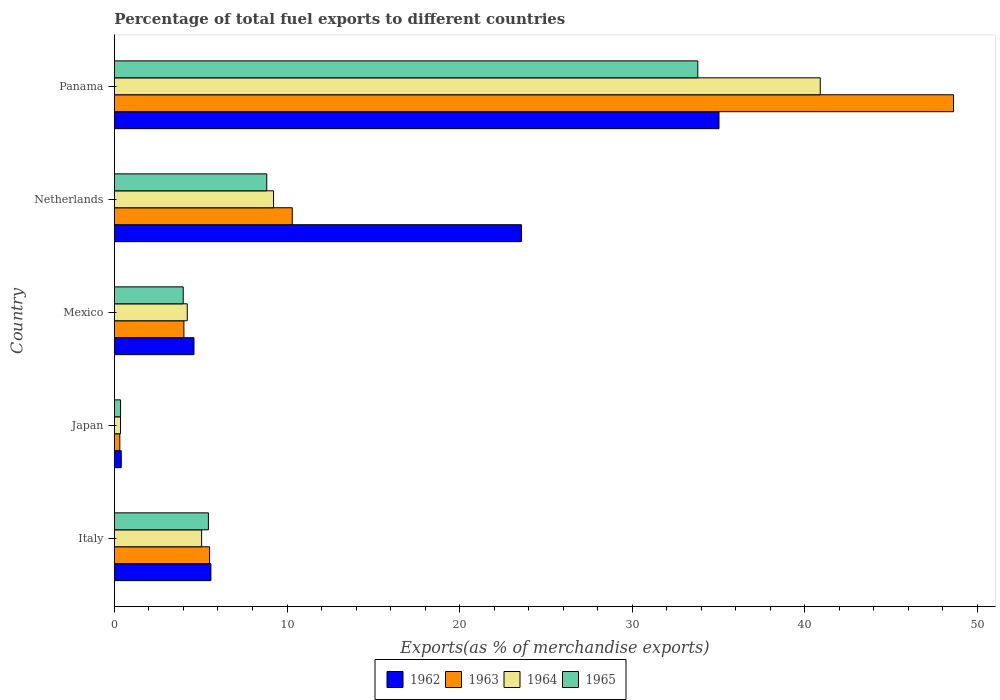Are the number of bars per tick equal to the number of legend labels?
Provide a succinct answer. Yes. What is the label of the 3rd group of bars from the top?
Provide a succinct answer. Mexico. In how many cases, is the number of bars for a given country not equal to the number of legend labels?
Your response must be concise. 0. What is the percentage of exports to different countries in 1965 in Mexico?
Offer a terse response. 3.99. Across all countries, what is the maximum percentage of exports to different countries in 1965?
Give a very brief answer. 33.8. Across all countries, what is the minimum percentage of exports to different countries in 1962?
Offer a very short reply. 0.4. In which country was the percentage of exports to different countries in 1965 maximum?
Make the answer very short. Panama. What is the total percentage of exports to different countries in 1965 in the graph?
Offer a terse response. 52.41. What is the difference between the percentage of exports to different countries in 1963 in Italy and that in Japan?
Ensure brevity in your answer.  5.2. What is the difference between the percentage of exports to different countries in 1963 in Italy and the percentage of exports to different countries in 1964 in Mexico?
Offer a very short reply. 1.29. What is the average percentage of exports to different countries in 1964 per country?
Offer a terse response. 11.95. What is the difference between the percentage of exports to different countries in 1963 and percentage of exports to different countries in 1964 in Japan?
Make the answer very short. -0.04. What is the ratio of the percentage of exports to different countries in 1964 in Japan to that in Mexico?
Make the answer very short. 0.08. Is the percentage of exports to different countries in 1965 in Mexico less than that in Panama?
Your answer should be compact. Yes. Is the difference between the percentage of exports to different countries in 1963 in Italy and Mexico greater than the difference between the percentage of exports to different countries in 1964 in Italy and Mexico?
Keep it short and to the point. Yes. What is the difference between the highest and the second highest percentage of exports to different countries in 1964?
Ensure brevity in your answer.  31.68. What is the difference between the highest and the lowest percentage of exports to different countries in 1965?
Your answer should be very brief. 33.45. Is the sum of the percentage of exports to different countries in 1962 in Mexico and Panama greater than the maximum percentage of exports to different countries in 1963 across all countries?
Give a very brief answer. No. Is it the case that in every country, the sum of the percentage of exports to different countries in 1965 and percentage of exports to different countries in 1964 is greater than the sum of percentage of exports to different countries in 1963 and percentage of exports to different countries in 1962?
Make the answer very short. No. What does the 1st bar from the top in Panama represents?
Your answer should be very brief. 1965. What does the 2nd bar from the bottom in Italy represents?
Provide a succinct answer. 1963. Are all the bars in the graph horizontal?
Your answer should be very brief. Yes. Does the graph contain grids?
Your answer should be very brief. No. Where does the legend appear in the graph?
Provide a succinct answer. Bottom center. How are the legend labels stacked?
Offer a terse response. Horizontal. What is the title of the graph?
Provide a short and direct response. Percentage of total fuel exports to different countries. Does "2003" appear as one of the legend labels in the graph?
Your response must be concise. No. What is the label or title of the X-axis?
Provide a short and direct response. Exports(as % of merchandise exports). What is the label or title of the Y-axis?
Your answer should be very brief. Country. What is the Exports(as % of merchandise exports) in 1962 in Italy?
Provide a succinct answer. 5.59. What is the Exports(as % of merchandise exports) in 1963 in Italy?
Give a very brief answer. 5.51. What is the Exports(as % of merchandise exports) of 1964 in Italy?
Your answer should be very brief. 5.05. What is the Exports(as % of merchandise exports) of 1965 in Italy?
Ensure brevity in your answer.  5.45. What is the Exports(as % of merchandise exports) in 1962 in Japan?
Your answer should be compact. 0.4. What is the Exports(as % of merchandise exports) in 1963 in Japan?
Your answer should be compact. 0.31. What is the Exports(as % of merchandise exports) in 1964 in Japan?
Provide a succinct answer. 0.35. What is the Exports(as % of merchandise exports) of 1965 in Japan?
Offer a very short reply. 0.36. What is the Exports(as % of merchandise exports) in 1962 in Mexico?
Keep it short and to the point. 4.61. What is the Exports(as % of merchandise exports) in 1963 in Mexico?
Ensure brevity in your answer.  4.03. What is the Exports(as % of merchandise exports) of 1964 in Mexico?
Provide a succinct answer. 4.22. What is the Exports(as % of merchandise exports) of 1965 in Mexico?
Your answer should be very brief. 3.99. What is the Exports(as % of merchandise exports) of 1962 in Netherlands?
Give a very brief answer. 23.58. What is the Exports(as % of merchandise exports) of 1963 in Netherlands?
Give a very brief answer. 10.31. What is the Exports(as % of merchandise exports) of 1964 in Netherlands?
Offer a very short reply. 9.22. What is the Exports(as % of merchandise exports) of 1965 in Netherlands?
Give a very brief answer. 8.83. What is the Exports(as % of merchandise exports) of 1962 in Panama?
Make the answer very short. 35.03. What is the Exports(as % of merchandise exports) in 1963 in Panama?
Your answer should be very brief. 48.62. What is the Exports(as % of merchandise exports) of 1964 in Panama?
Make the answer very short. 40.9. What is the Exports(as % of merchandise exports) of 1965 in Panama?
Give a very brief answer. 33.8. Across all countries, what is the maximum Exports(as % of merchandise exports) of 1962?
Ensure brevity in your answer.  35.03. Across all countries, what is the maximum Exports(as % of merchandise exports) of 1963?
Your answer should be compact. 48.62. Across all countries, what is the maximum Exports(as % of merchandise exports) in 1964?
Your answer should be very brief. 40.9. Across all countries, what is the maximum Exports(as % of merchandise exports) of 1965?
Your answer should be compact. 33.8. Across all countries, what is the minimum Exports(as % of merchandise exports) of 1962?
Your response must be concise. 0.4. Across all countries, what is the minimum Exports(as % of merchandise exports) in 1963?
Your response must be concise. 0.31. Across all countries, what is the minimum Exports(as % of merchandise exports) of 1964?
Offer a very short reply. 0.35. Across all countries, what is the minimum Exports(as % of merchandise exports) in 1965?
Your answer should be compact. 0.36. What is the total Exports(as % of merchandise exports) of 1962 in the graph?
Make the answer very short. 69.21. What is the total Exports(as % of merchandise exports) in 1963 in the graph?
Provide a succinct answer. 68.78. What is the total Exports(as % of merchandise exports) in 1964 in the graph?
Provide a succinct answer. 59.74. What is the total Exports(as % of merchandise exports) of 1965 in the graph?
Your response must be concise. 52.41. What is the difference between the Exports(as % of merchandise exports) of 1962 in Italy and that in Japan?
Ensure brevity in your answer.  5.19. What is the difference between the Exports(as % of merchandise exports) in 1963 in Italy and that in Japan?
Keep it short and to the point. 5.2. What is the difference between the Exports(as % of merchandise exports) of 1964 in Italy and that in Japan?
Make the answer very short. 4.7. What is the difference between the Exports(as % of merchandise exports) of 1965 in Italy and that in Japan?
Your answer should be very brief. 5.09. What is the difference between the Exports(as % of merchandise exports) of 1962 in Italy and that in Mexico?
Provide a short and direct response. 0.98. What is the difference between the Exports(as % of merchandise exports) in 1963 in Italy and that in Mexico?
Offer a terse response. 1.49. What is the difference between the Exports(as % of merchandise exports) of 1964 in Italy and that in Mexico?
Provide a short and direct response. 0.83. What is the difference between the Exports(as % of merchandise exports) in 1965 in Italy and that in Mexico?
Ensure brevity in your answer.  1.46. What is the difference between the Exports(as % of merchandise exports) of 1962 in Italy and that in Netherlands?
Your answer should be compact. -17.99. What is the difference between the Exports(as % of merchandise exports) of 1963 in Italy and that in Netherlands?
Provide a short and direct response. -4.79. What is the difference between the Exports(as % of merchandise exports) of 1964 in Italy and that in Netherlands?
Your response must be concise. -4.17. What is the difference between the Exports(as % of merchandise exports) in 1965 in Italy and that in Netherlands?
Offer a very short reply. -3.38. What is the difference between the Exports(as % of merchandise exports) in 1962 in Italy and that in Panama?
Ensure brevity in your answer.  -29.44. What is the difference between the Exports(as % of merchandise exports) in 1963 in Italy and that in Panama?
Offer a terse response. -43.11. What is the difference between the Exports(as % of merchandise exports) of 1964 in Italy and that in Panama?
Offer a very short reply. -35.85. What is the difference between the Exports(as % of merchandise exports) of 1965 in Italy and that in Panama?
Ensure brevity in your answer.  -28.36. What is the difference between the Exports(as % of merchandise exports) in 1962 in Japan and that in Mexico?
Give a very brief answer. -4.21. What is the difference between the Exports(as % of merchandise exports) in 1963 in Japan and that in Mexico?
Your response must be concise. -3.71. What is the difference between the Exports(as % of merchandise exports) of 1964 in Japan and that in Mexico?
Ensure brevity in your answer.  -3.87. What is the difference between the Exports(as % of merchandise exports) of 1965 in Japan and that in Mexico?
Provide a succinct answer. -3.63. What is the difference between the Exports(as % of merchandise exports) of 1962 in Japan and that in Netherlands?
Offer a terse response. -23.19. What is the difference between the Exports(as % of merchandise exports) in 1963 in Japan and that in Netherlands?
Your answer should be compact. -9.99. What is the difference between the Exports(as % of merchandise exports) of 1964 in Japan and that in Netherlands?
Ensure brevity in your answer.  -8.87. What is the difference between the Exports(as % of merchandise exports) in 1965 in Japan and that in Netherlands?
Keep it short and to the point. -8.47. What is the difference between the Exports(as % of merchandise exports) in 1962 in Japan and that in Panama?
Offer a very short reply. -34.63. What is the difference between the Exports(as % of merchandise exports) of 1963 in Japan and that in Panama?
Give a very brief answer. -48.31. What is the difference between the Exports(as % of merchandise exports) in 1964 in Japan and that in Panama?
Offer a very short reply. -40.54. What is the difference between the Exports(as % of merchandise exports) in 1965 in Japan and that in Panama?
Your answer should be very brief. -33.45. What is the difference between the Exports(as % of merchandise exports) of 1962 in Mexico and that in Netherlands?
Offer a terse response. -18.97. What is the difference between the Exports(as % of merchandise exports) in 1963 in Mexico and that in Netherlands?
Your response must be concise. -6.28. What is the difference between the Exports(as % of merchandise exports) in 1964 in Mexico and that in Netherlands?
Your answer should be very brief. -5. What is the difference between the Exports(as % of merchandise exports) in 1965 in Mexico and that in Netherlands?
Your answer should be very brief. -4.84. What is the difference between the Exports(as % of merchandise exports) in 1962 in Mexico and that in Panama?
Offer a terse response. -30.42. What is the difference between the Exports(as % of merchandise exports) in 1963 in Mexico and that in Panama?
Offer a very short reply. -44.59. What is the difference between the Exports(as % of merchandise exports) of 1964 in Mexico and that in Panama?
Offer a terse response. -36.68. What is the difference between the Exports(as % of merchandise exports) of 1965 in Mexico and that in Panama?
Keep it short and to the point. -29.82. What is the difference between the Exports(as % of merchandise exports) in 1962 in Netherlands and that in Panama?
Offer a very short reply. -11.45. What is the difference between the Exports(as % of merchandise exports) of 1963 in Netherlands and that in Panama?
Offer a terse response. -38.32. What is the difference between the Exports(as % of merchandise exports) in 1964 in Netherlands and that in Panama?
Provide a short and direct response. -31.68. What is the difference between the Exports(as % of merchandise exports) of 1965 in Netherlands and that in Panama?
Offer a very short reply. -24.98. What is the difference between the Exports(as % of merchandise exports) in 1962 in Italy and the Exports(as % of merchandise exports) in 1963 in Japan?
Provide a short and direct response. 5.28. What is the difference between the Exports(as % of merchandise exports) of 1962 in Italy and the Exports(as % of merchandise exports) of 1964 in Japan?
Your response must be concise. 5.24. What is the difference between the Exports(as % of merchandise exports) in 1962 in Italy and the Exports(as % of merchandise exports) in 1965 in Japan?
Your response must be concise. 5.23. What is the difference between the Exports(as % of merchandise exports) in 1963 in Italy and the Exports(as % of merchandise exports) in 1964 in Japan?
Keep it short and to the point. 5.16. What is the difference between the Exports(as % of merchandise exports) of 1963 in Italy and the Exports(as % of merchandise exports) of 1965 in Japan?
Your response must be concise. 5.16. What is the difference between the Exports(as % of merchandise exports) in 1964 in Italy and the Exports(as % of merchandise exports) in 1965 in Japan?
Make the answer very short. 4.7. What is the difference between the Exports(as % of merchandise exports) of 1962 in Italy and the Exports(as % of merchandise exports) of 1963 in Mexico?
Provide a succinct answer. 1.56. What is the difference between the Exports(as % of merchandise exports) of 1962 in Italy and the Exports(as % of merchandise exports) of 1964 in Mexico?
Ensure brevity in your answer.  1.37. What is the difference between the Exports(as % of merchandise exports) of 1962 in Italy and the Exports(as % of merchandise exports) of 1965 in Mexico?
Provide a short and direct response. 1.6. What is the difference between the Exports(as % of merchandise exports) of 1963 in Italy and the Exports(as % of merchandise exports) of 1964 in Mexico?
Offer a very short reply. 1.29. What is the difference between the Exports(as % of merchandise exports) of 1963 in Italy and the Exports(as % of merchandise exports) of 1965 in Mexico?
Your answer should be very brief. 1.53. What is the difference between the Exports(as % of merchandise exports) in 1964 in Italy and the Exports(as % of merchandise exports) in 1965 in Mexico?
Your response must be concise. 1.07. What is the difference between the Exports(as % of merchandise exports) in 1962 in Italy and the Exports(as % of merchandise exports) in 1963 in Netherlands?
Your answer should be compact. -4.72. What is the difference between the Exports(as % of merchandise exports) in 1962 in Italy and the Exports(as % of merchandise exports) in 1964 in Netherlands?
Give a very brief answer. -3.63. What is the difference between the Exports(as % of merchandise exports) in 1962 in Italy and the Exports(as % of merchandise exports) in 1965 in Netherlands?
Offer a terse response. -3.24. What is the difference between the Exports(as % of merchandise exports) in 1963 in Italy and the Exports(as % of merchandise exports) in 1964 in Netherlands?
Make the answer very short. -3.71. What is the difference between the Exports(as % of merchandise exports) in 1963 in Italy and the Exports(as % of merchandise exports) in 1965 in Netherlands?
Make the answer very short. -3.31. What is the difference between the Exports(as % of merchandise exports) in 1964 in Italy and the Exports(as % of merchandise exports) in 1965 in Netherlands?
Keep it short and to the point. -3.77. What is the difference between the Exports(as % of merchandise exports) in 1962 in Italy and the Exports(as % of merchandise exports) in 1963 in Panama?
Provide a succinct answer. -43.03. What is the difference between the Exports(as % of merchandise exports) in 1962 in Italy and the Exports(as % of merchandise exports) in 1964 in Panama?
Provide a short and direct response. -35.31. What is the difference between the Exports(as % of merchandise exports) of 1962 in Italy and the Exports(as % of merchandise exports) of 1965 in Panama?
Provide a short and direct response. -28.21. What is the difference between the Exports(as % of merchandise exports) of 1963 in Italy and the Exports(as % of merchandise exports) of 1964 in Panama?
Keep it short and to the point. -35.38. What is the difference between the Exports(as % of merchandise exports) of 1963 in Italy and the Exports(as % of merchandise exports) of 1965 in Panama?
Make the answer very short. -28.29. What is the difference between the Exports(as % of merchandise exports) in 1964 in Italy and the Exports(as % of merchandise exports) in 1965 in Panama?
Provide a short and direct response. -28.75. What is the difference between the Exports(as % of merchandise exports) of 1962 in Japan and the Exports(as % of merchandise exports) of 1963 in Mexico?
Offer a very short reply. -3.63. What is the difference between the Exports(as % of merchandise exports) of 1962 in Japan and the Exports(as % of merchandise exports) of 1964 in Mexico?
Offer a very short reply. -3.82. What is the difference between the Exports(as % of merchandise exports) in 1962 in Japan and the Exports(as % of merchandise exports) in 1965 in Mexico?
Offer a terse response. -3.59. What is the difference between the Exports(as % of merchandise exports) in 1963 in Japan and the Exports(as % of merchandise exports) in 1964 in Mexico?
Your answer should be compact. -3.91. What is the difference between the Exports(as % of merchandise exports) of 1963 in Japan and the Exports(as % of merchandise exports) of 1965 in Mexico?
Make the answer very short. -3.67. What is the difference between the Exports(as % of merchandise exports) in 1964 in Japan and the Exports(as % of merchandise exports) in 1965 in Mexico?
Your answer should be compact. -3.63. What is the difference between the Exports(as % of merchandise exports) of 1962 in Japan and the Exports(as % of merchandise exports) of 1963 in Netherlands?
Offer a terse response. -9.91. What is the difference between the Exports(as % of merchandise exports) in 1962 in Japan and the Exports(as % of merchandise exports) in 1964 in Netherlands?
Make the answer very short. -8.82. What is the difference between the Exports(as % of merchandise exports) of 1962 in Japan and the Exports(as % of merchandise exports) of 1965 in Netherlands?
Ensure brevity in your answer.  -8.43. What is the difference between the Exports(as % of merchandise exports) of 1963 in Japan and the Exports(as % of merchandise exports) of 1964 in Netherlands?
Offer a terse response. -8.91. What is the difference between the Exports(as % of merchandise exports) in 1963 in Japan and the Exports(as % of merchandise exports) in 1965 in Netherlands?
Your response must be concise. -8.51. What is the difference between the Exports(as % of merchandise exports) in 1964 in Japan and the Exports(as % of merchandise exports) in 1965 in Netherlands?
Provide a succinct answer. -8.47. What is the difference between the Exports(as % of merchandise exports) in 1962 in Japan and the Exports(as % of merchandise exports) in 1963 in Panama?
Give a very brief answer. -48.22. What is the difference between the Exports(as % of merchandise exports) of 1962 in Japan and the Exports(as % of merchandise exports) of 1964 in Panama?
Make the answer very short. -40.5. What is the difference between the Exports(as % of merchandise exports) of 1962 in Japan and the Exports(as % of merchandise exports) of 1965 in Panama?
Give a very brief answer. -33.41. What is the difference between the Exports(as % of merchandise exports) in 1963 in Japan and the Exports(as % of merchandise exports) in 1964 in Panama?
Give a very brief answer. -40.58. What is the difference between the Exports(as % of merchandise exports) of 1963 in Japan and the Exports(as % of merchandise exports) of 1965 in Panama?
Provide a succinct answer. -33.49. What is the difference between the Exports(as % of merchandise exports) of 1964 in Japan and the Exports(as % of merchandise exports) of 1965 in Panama?
Offer a terse response. -33.45. What is the difference between the Exports(as % of merchandise exports) of 1962 in Mexico and the Exports(as % of merchandise exports) of 1963 in Netherlands?
Offer a terse response. -5.7. What is the difference between the Exports(as % of merchandise exports) in 1962 in Mexico and the Exports(as % of merchandise exports) in 1964 in Netherlands?
Provide a succinct answer. -4.61. What is the difference between the Exports(as % of merchandise exports) in 1962 in Mexico and the Exports(as % of merchandise exports) in 1965 in Netherlands?
Give a very brief answer. -4.22. What is the difference between the Exports(as % of merchandise exports) in 1963 in Mexico and the Exports(as % of merchandise exports) in 1964 in Netherlands?
Make the answer very short. -5.19. What is the difference between the Exports(as % of merchandise exports) of 1963 in Mexico and the Exports(as % of merchandise exports) of 1965 in Netherlands?
Your response must be concise. -4.8. What is the difference between the Exports(as % of merchandise exports) of 1964 in Mexico and the Exports(as % of merchandise exports) of 1965 in Netherlands?
Your answer should be very brief. -4.61. What is the difference between the Exports(as % of merchandise exports) in 1962 in Mexico and the Exports(as % of merchandise exports) in 1963 in Panama?
Keep it short and to the point. -44.01. What is the difference between the Exports(as % of merchandise exports) of 1962 in Mexico and the Exports(as % of merchandise exports) of 1964 in Panama?
Make the answer very short. -36.29. What is the difference between the Exports(as % of merchandise exports) in 1962 in Mexico and the Exports(as % of merchandise exports) in 1965 in Panama?
Make the answer very short. -29.19. What is the difference between the Exports(as % of merchandise exports) in 1963 in Mexico and the Exports(as % of merchandise exports) in 1964 in Panama?
Ensure brevity in your answer.  -36.87. What is the difference between the Exports(as % of merchandise exports) of 1963 in Mexico and the Exports(as % of merchandise exports) of 1965 in Panama?
Your answer should be very brief. -29.78. What is the difference between the Exports(as % of merchandise exports) of 1964 in Mexico and the Exports(as % of merchandise exports) of 1965 in Panama?
Offer a very short reply. -29.58. What is the difference between the Exports(as % of merchandise exports) in 1962 in Netherlands and the Exports(as % of merchandise exports) in 1963 in Panama?
Offer a terse response. -25.04. What is the difference between the Exports(as % of merchandise exports) of 1962 in Netherlands and the Exports(as % of merchandise exports) of 1964 in Panama?
Offer a very short reply. -17.31. What is the difference between the Exports(as % of merchandise exports) of 1962 in Netherlands and the Exports(as % of merchandise exports) of 1965 in Panama?
Make the answer very short. -10.22. What is the difference between the Exports(as % of merchandise exports) in 1963 in Netherlands and the Exports(as % of merchandise exports) in 1964 in Panama?
Keep it short and to the point. -30.59. What is the difference between the Exports(as % of merchandise exports) of 1963 in Netherlands and the Exports(as % of merchandise exports) of 1965 in Panama?
Make the answer very short. -23.5. What is the difference between the Exports(as % of merchandise exports) in 1964 in Netherlands and the Exports(as % of merchandise exports) in 1965 in Panama?
Your response must be concise. -24.58. What is the average Exports(as % of merchandise exports) of 1962 per country?
Offer a terse response. 13.84. What is the average Exports(as % of merchandise exports) of 1963 per country?
Your answer should be compact. 13.76. What is the average Exports(as % of merchandise exports) of 1964 per country?
Keep it short and to the point. 11.95. What is the average Exports(as % of merchandise exports) in 1965 per country?
Give a very brief answer. 10.48. What is the difference between the Exports(as % of merchandise exports) of 1962 and Exports(as % of merchandise exports) of 1963 in Italy?
Provide a succinct answer. 0.08. What is the difference between the Exports(as % of merchandise exports) in 1962 and Exports(as % of merchandise exports) in 1964 in Italy?
Provide a succinct answer. 0.54. What is the difference between the Exports(as % of merchandise exports) of 1962 and Exports(as % of merchandise exports) of 1965 in Italy?
Your answer should be compact. 0.14. What is the difference between the Exports(as % of merchandise exports) in 1963 and Exports(as % of merchandise exports) in 1964 in Italy?
Give a very brief answer. 0.46. What is the difference between the Exports(as % of merchandise exports) of 1963 and Exports(as % of merchandise exports) of 1965 in Italy?
Make the answer very short. 0.07. What is the difference between the Exports(as % of merchandise exports) in 1964 and Exports(as % of merchandise exports) in 1965 in Italy?
Give a very brief answer. -0.39. What is the difference between the Exports(as % of merchandise exports) in 1962 and Exports(as % of merchandise exports) in 1963 in Japan?
Ensure brevity in your answer.  0.08. What is the difference between the Exports(as % of merchandise exports) in 1962 and Exports(as % of merchandise exports) in 1964 in Japan?
Offer a terse response. 0.04. What is the difference between the Exports(as % of merchandise exports) in 1962 and Exports(as % of merchandise exports) in 1965 in Japan?
Give a very brief answer. 0.04. What is the difference between the Exports(as % of merchandise exports) of 1963 and Exports(as % of merchandise exports) of 1964 in Japan?
Give a very brief answer. -0.04. What is the difference between the Exports(as % of merchandise exports) of 1963 and Exports(as % of merchandise exports) of 1965 in Japan?
Provide a short and direct response. -0.04. What is the difference between the Exports(as % of merchandise exports) in 1964 and Exports(as % of merchandise exports) in 1965 in Japan?
Keep it short and to the point. -0. What is the difference between the Exports(as % of merchandise exports) of 1962 and Exports(as % of merchandise exports) of 1963 in Mexico?
Your response must be concise. 0.58. What is the difference between the Exports(as % of merchandise exports) in 1962 and Exports(as % of merchandise exports) in 1964 in Mexico?
Provide a short and direct response. 0.39. What is the difference between the Exports(as % of merchandise exports) in 1962 and Exports(as % of merchandise exports) in 1965 in Mexico?
Your answer should be compact. 0.62. What is the difference between the Exports(as % of merchandise exports) in 1963 and Exports(as % of merchandise exports) in 1964 in Mexico?
Make the answer very short. -0.19. What is the difference between the Exports(as % of merchandise exports) in 1963 and Exports(as % of merchandise exports) in 1965 in Mexico?
Ensure brevity in your answer.  0.04. What is the difference between the Exports(as % of merchandise exports) of 1964 and Exports(as % of merchandise exports) of 1965 in Mexico?
Give a very brief answer. 0.23. What is the difference between the Exports(as % of merchandise exports) in 1962 and Exports(as % of merchandise exports) in 1963 in Netherlands?
Your answer should be very brief. 13.28. What is the difference between the Exports(as % of merchandise exports) in 1962 and Exports(as % of merchandise exports) in 1964 in Netherlands?
Provide a succinct answer. 14.36. What is the difference between the Exports(as % of merchandise exports) of 1962 and Exports(as % of merchandise exports) of 1965 in Netherlands?
Offer a very short reply. 14.76. What is the difference between the Exports(as % of merchandise exports) in 1963 and Exports(as % of merchandise exports) in 1964 in Netherlands?
Give a very brief answer. 1.09. What is the difference between the Exports(as % of merchandise exports) of 1963 and Exports(as % of merchandise exports) of 1965 in Netherlands?
Give a very brief answer. 1.48. What is the difference between the Exports(as % of merchandise exports) in 1964 and Exports(as % of merchandise exports) in 1965 in Netherlands?
Offer a terse response. 0.39. What is the difference between the Exports(as % of merchandise exports) of 1962 and Exports(as % of merchandise exports) of 1963 in Panama?
Offer a terse response. -13.59. What is the difference between the Exports(as % of merchandise exports) in 1962 and Exports(as % of merchandise exports) in 1964 in Panama?
Provide a succinct answer. -5.87. What is the difference between the Exports(as % of merchandise exports) in 1962 and Exports(as % of merchandise exports) in 1965 in Panama?
Keep it short and to the point. 1.23. What is the difference between the Exports(as % of merchandise exports) in 1963 and Exports(as % of merchandise exports) in 1964 in Panama?
Provide a succinct answer. 7.72. What is the difference between the Exports(as % of merchandise exports) in 1963 and Exports(as % of merchandise exports) in 1965 in Panama?
Your answer should be compact. 14.82. What is the difference between the Exports(as % of merchandise exports) in 1964 and Exports(as % of merchandise exports) in 1965 in Panama?
Provide a succinct answer. 7.1. What is the ratio of the Exports(as % of merchandise exports) of 1962 in Italy to that in Japan?
Your answer should be very brief. 14.1. What is the ratio of the Exports(as % of merchandise exports) in 1963 in Italy to that in Japan?
Provide a succinct answer. 17.64. What is the ratio of the Exports(as % of merchandise exports) in 1964 in Italy to that in Japan?
Keep it short and to the point. 14.31. What is the ratio of the Exports(as % of merchandise exports) in 1965 in Italy to that in Japan?
Provide a succinct answer. 15.32. What is the ratio of the Exports(as % of merchandise exports) of 1962 in Italy to that in Mexico?
Keep it short and to the point. 1.21. What is the ratio of the Exports(as % of merchandise exports) of 1963 in Italy to that in Mexico?
Provide a short and direct response. 1.37. What is the ratio of the Exports(as % of merchandise exports) of 1964 in Italy to that in Mexico?
Offer a terse response. 1.2. What is the ratio of the Exports(as % of merchandise exports) of 1965 in Italy to that in Mexico?
Offer a very short reply. 1.37. What is the ratio of the Exports(as % of merchandise exports) of 1962 in Italy to that in Netherlands?
Provide a short and direct response. 0.24. What is the ratio of the Exports(as % of merchandise exports) of 1963 in Italy to that in Netherlands?
Ensure brevity in your answer.  0.54. What is the ratio of the Exports(as % of merchandise exports) of 1964 in Italy to that in Netherlands?
Keep it short and to the point. 0.55. What is the ratio of the Exports(as % of merchandise exports) in 1965 in Italy to that in Netherlands?
Ensure brevity in your answer.  0.62. What is the ratio of the Exports(as % of merchandise exports) of 1962 in Italy to that in Panama?
Keep it short and to the point. 0.16. What is the ratio of the Exports(as % of merchandise exports) in 1963 in Italy to that in Panama?
Make the answer very short. 0.11. What is the ratio of the Exports(as % of merchandise exports) of 1964 in Italy to that in Panama?
Ensure brevity in your answer.  0.12. What is the ratio of the Exports(as % of merchandise exports) in 1965 in Italy to that in Panama?
Your answer should be very brief. 0.16. What is the ratio of the Exports(as % of merchandise exports) in 1962 in Japan to that in Mexico?
Give a very brief answer. 0.09. What is the ratio of the Exports(as % of merchandise exports) of 1963 in Japan to that in Mexico?
Offer a very short reply. 0.08. What is the ratio of the Exports(as % of merchandise exports) in 1964 in Japan to that in Mexico?
Your answer should be very brief. 0.08. What is the ratio of the Exports(as % of merchandise exports) in 1965 in Japan to that in Mexico?
Make the answer very short. 0.09. What is the ratio of the Exports(as % of merchandise exports) in 1962 in Japan to that in Netherlands?
Ensure brevity in your answer.  0.02. What is the ratio of the Exports(as % of merchandise exports) of 1963 in Japan to that in Netherlands?
Give a very brief answer. 0.03. What is the ratio of the Exports(as % of merchandise exports) in 1964 in Japan to that in Netherlands?
Ensure brevity in your answer.  0.04. What is the ratio of the Exports(as % of merchandise exports) of 1965 in Japan to that in Netherlands?
Provide a short and direct response. 0.04. What is the ratio of the Exports(as % of merchandise exports) of 1962 in Japan to that in Panama?
Provide a short and direct response. 0.01. What is the ratio of the Exports(as % of merchandise exports) in 1963 in Japan to that in Panama?
Keep it short and to the point. 0.01. What is the ratio of the Exports(as % of merchandise exports) in 1964 in Japan to that in Panama?
Provide a short and direct response. 0.01. What is the ratio of the Exports(as % of merchandise exports) in 1965 in Japan to that in Panama?
Your response must be concise. 0.01. What is the ratio of the Exports(as % of merchandise exports) in 1962 in Mexico to that in Netherlands?
Give a very brief answer. 0.2. What is the ratio of the Exports(as % of merchandise exports) of 1963 in Mexico to that in Netherlands?
Provide a short and direct response. 0.39. What is the ratio of the Exports(as % of merchandise exports) of 1964 in Mexico to that in Netherlands?
Your answer should be compact. 0.46. What is the ratio of the Exports(as % of merchandise exports) in 1965 in Mexico to that in Netherlands?
Make the answer very short. 0.45. What is the ratio of the Exports(as % of merchandise exports) in 1962 in Mexico to that in Panama?
Your response must be concise. 0.13. What is the ratio of the Exports(as % of merchandise exports) in 1963 in Mexico to that in Panama?
Ensure brevity in your answer.  0.08. What is the ratio of the Exports(as % of merchandise exports) of 1964 in Mexico to that in Panama?
Offer a terse response. 0.1. What is the ratio of the Exports(as % of merchandise exports) of 1965 in Mexico to that in Panama?
Ensure brevity in your answer.  0.12. What is the ratio of the Exports(as % of merchandise exports) of 1962 in Netherlands to that in Panama?
Your answer should be very brief. 0.67. What is the ratio of the Exports(as % of merchandise exports) in 1963 in Netherlands to that in Panama?
Provide a short and direct response. 0.21. What is the ratio of the Exports(as % of merchandise exports) in 1964 in Netherlands to that in Panama?
Offer a terse response. 0.23. What is the ratio of the Exports(as % of merchandise exports) in 1965 in Netherlands to that in Panama?
Offer a terse response. 0.26. What is the difference between the highest and the second highest Exports(as % of merchandise exports) in 1962?
Offer a terse response. 11.45. What is the difference between the highest and the second highest Exports(as % of merchandise exports) in 1963?
Give a very brief answer. 38.32. What is the difference between the highest and the second highest Exports(as % of merchandise exports) in 1964?
Provide a short and direct response. 31.68. What is the difference between the highest and the second highest Exports(as % of merchandise exports) in 1965?
Your answer should be compact. 24.98. What is the difference between the highest and the lowest Exports(as % of merchandise exports) in 1962?
Provide a succinct answer. 34.63. What is the difference between the highest and the lowest Exports(as % of merchandise exports) of 1963?
Offer a very short reply. 48.31. What is the difference between the highest and the lowest Exports(as % of merchandise exports) in 1964?
Keep it short and to the point. 40.54. What is the difference between the highest and the lowest Exports(as % of merchandise exports) in 1965?
Offer a terse response. 33.45. 